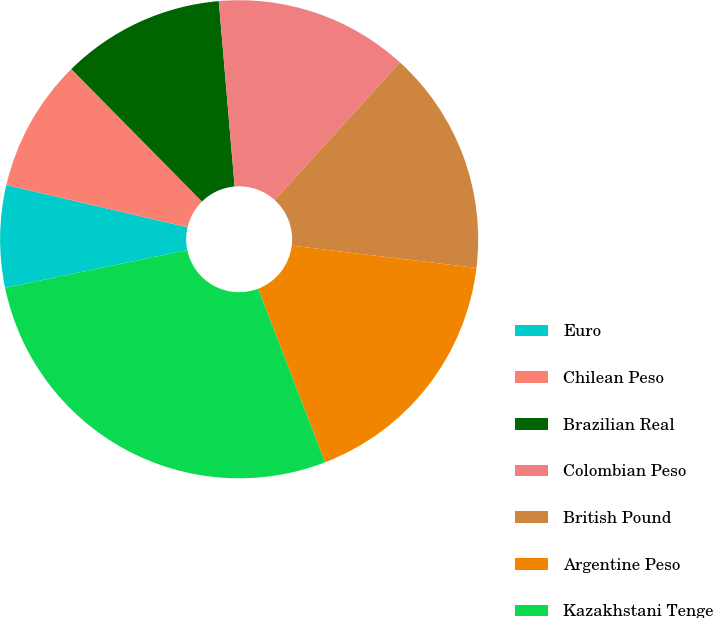Convert chart. <chart><loc_0><loc_0><loc_500><loc_500><pie_chart><fcel>Euro<fcel>Chilean Peso<fcel>Brazilian Real<fcel>Colombian Peso<fcel>British Pound<fcel>Argentine Peso<fcel>Kazakhstani Tenge<nl><fcel>6.9%<fcel>8.97%<fcel>11.03%<fcel>13.1%<fcel>15.17%<fcel>17.24%<fcel>27.59%<nl></chart> 